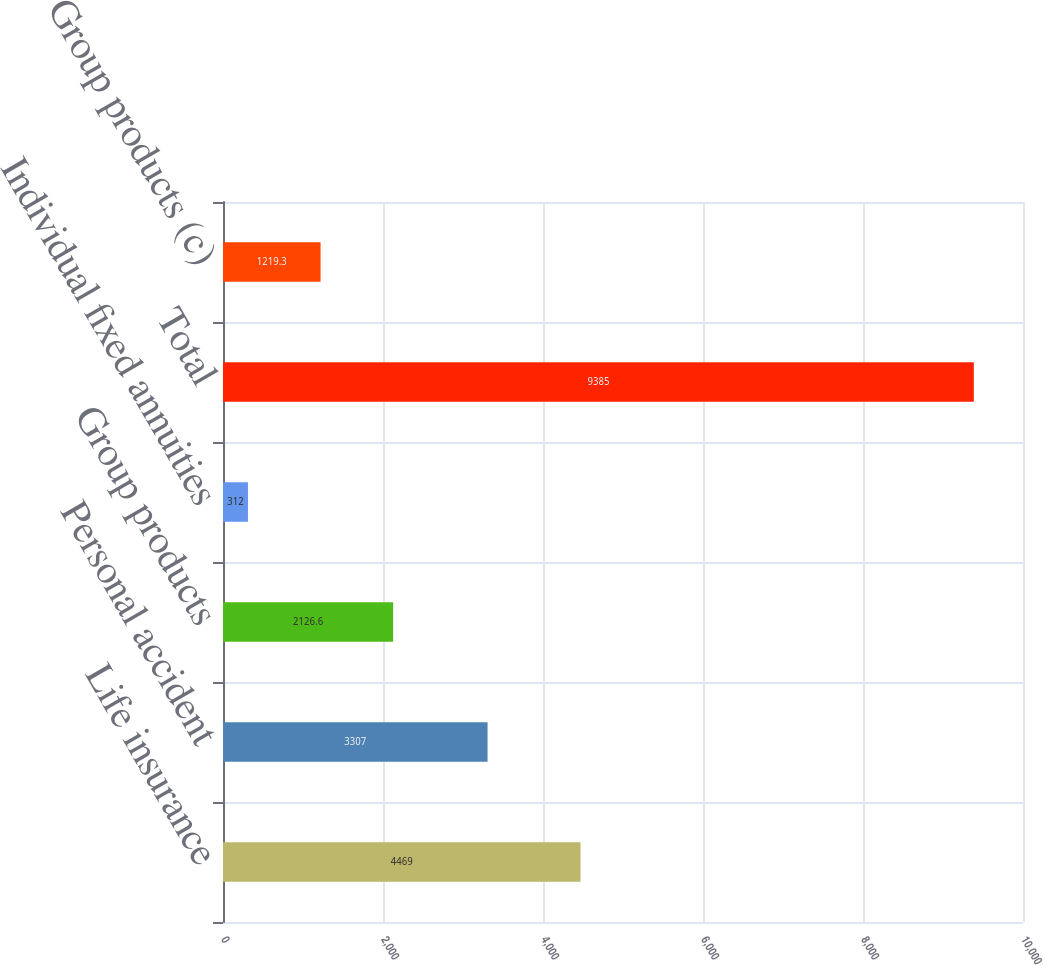Convert chart. <chart><loc_0><loc_0><loc_500><loc_500><bar_chart><fcel>Life insurance<fcel>Personal accident<fcel>Group products<fcel>Individual fixed annuities<fcel>Total<fcel>Group products (c)<nl><fcel>4469<fcel>3307<fcel>2126.6<fcel>312<fcel>9385<fcel>1219.3<nl></chart> 